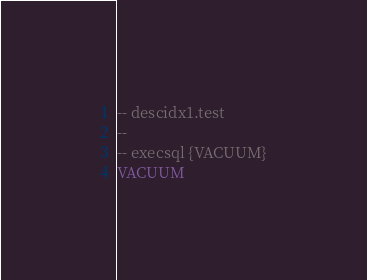<code> <loc_0><loc_0><loc_500><loc_500><_SQL_>-- descidx1.test
-- 
-- execsql {VACUUM}
VACUUM</code> 